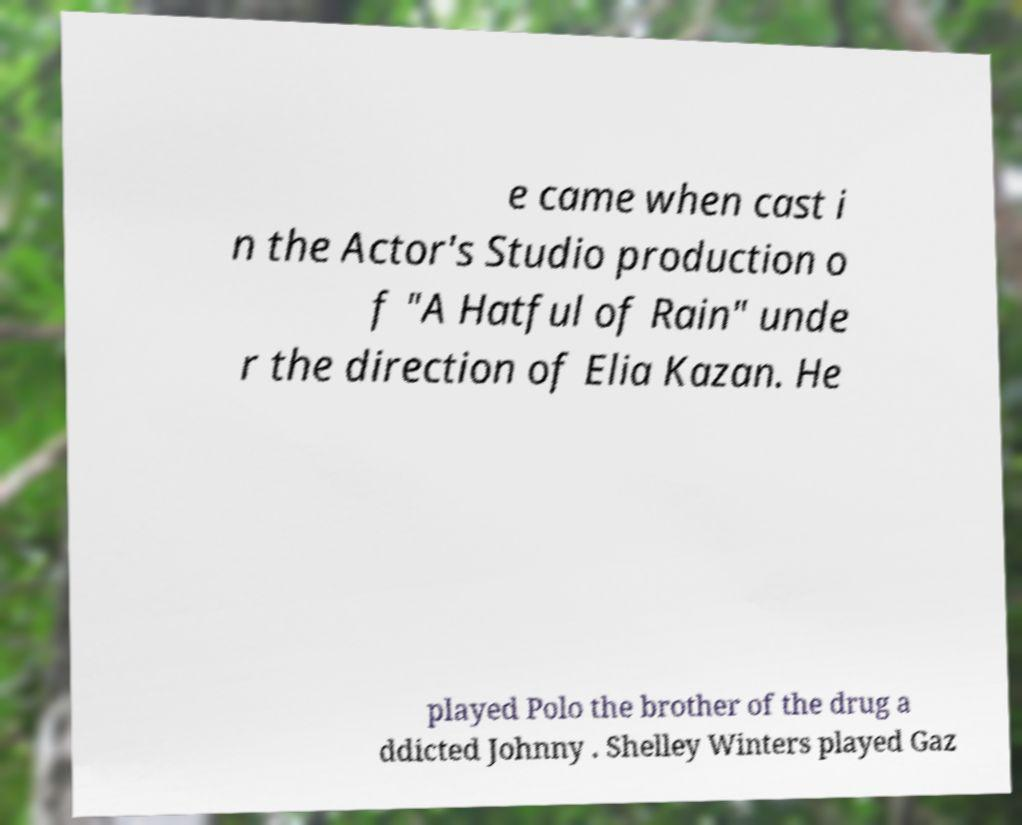Can you read and provide the text displayed in the image?This photo seems to have some interesting text. Can you extract and type it out for me? e came when cast i n the Actor's Studio production o f "A Hatful of Rain" unde r the direction of Elia Kazan. He played Polo the brother of the drug a ddicted Johnny . Shelley Winters played Gaz 